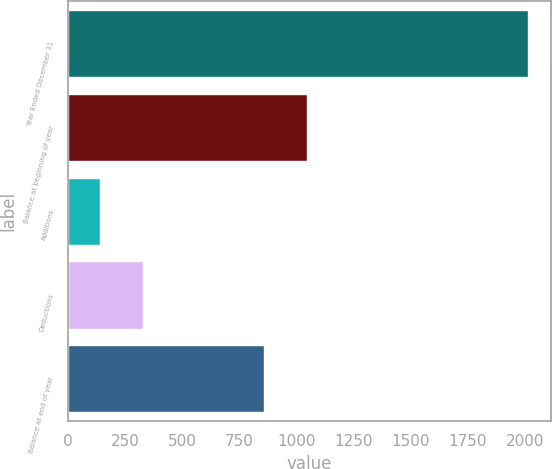Convert chart to OTSL. <chart><loc_0><loc_0><loc_500><loc_500><bar_chart><fcel>Year Ended December 31<fcel>Balance at beginning of year<fcel>Additions<fcel>Deductions<fcel>Balance at end of year<nl><fcel>2011<fcel>1046.3<fcel>138<fcel>325.3<fcel>859<nl></chart> 